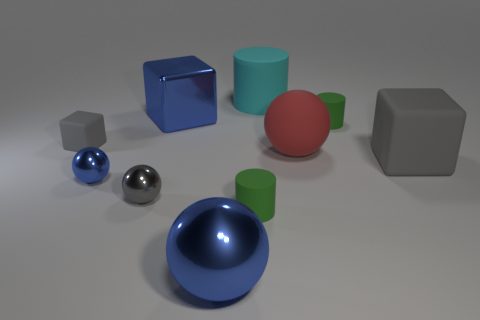What number of big red objects are made of the same material as the tiny gray block?
Your answer should be very brief. 1. What number of objects are either big things to the right of the blue metallic cube or rubber cylinders that are behind the small gray rubber thing?
Give a very brief answer. 5. Is the number of cyan rubber things that are behind the big blue metal cube greater than the number of blue spheres to the right of the cyan rubber cylinder?
Your answer should be very brief. Yes. There is a rubber cylinder that is in front of the small blue sphere; what is its color?
Keep it short and to the point. Green. Is there a large gray matte object that has the same shape as the tiny gray rubber object?
Give a very brief answer. Yes. What number of blue objects are either big shiny objects or large rubber cylinders?
Offer a terse response. 2. Is there a green matte object that has the same size as the cyan cylinder?
Provide a short and direct response. No. What number of blue metal objects are there?
Ensure brevity in your answer.  3. How many big objects are green cylinders or blue metal things?
Your answer should be compact. 2. What color is the tiny metal ball on the right side of the blue metallic object left of the big blue object behind the large gray block?
Offer a terse response. Gray. 